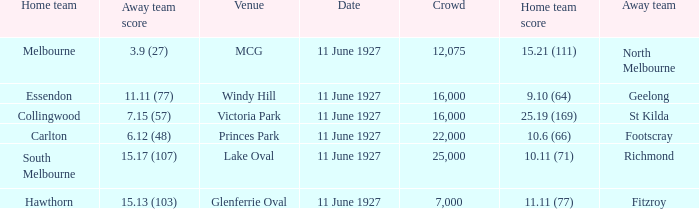Which home team competed against the away team Geelong? Essendon. 